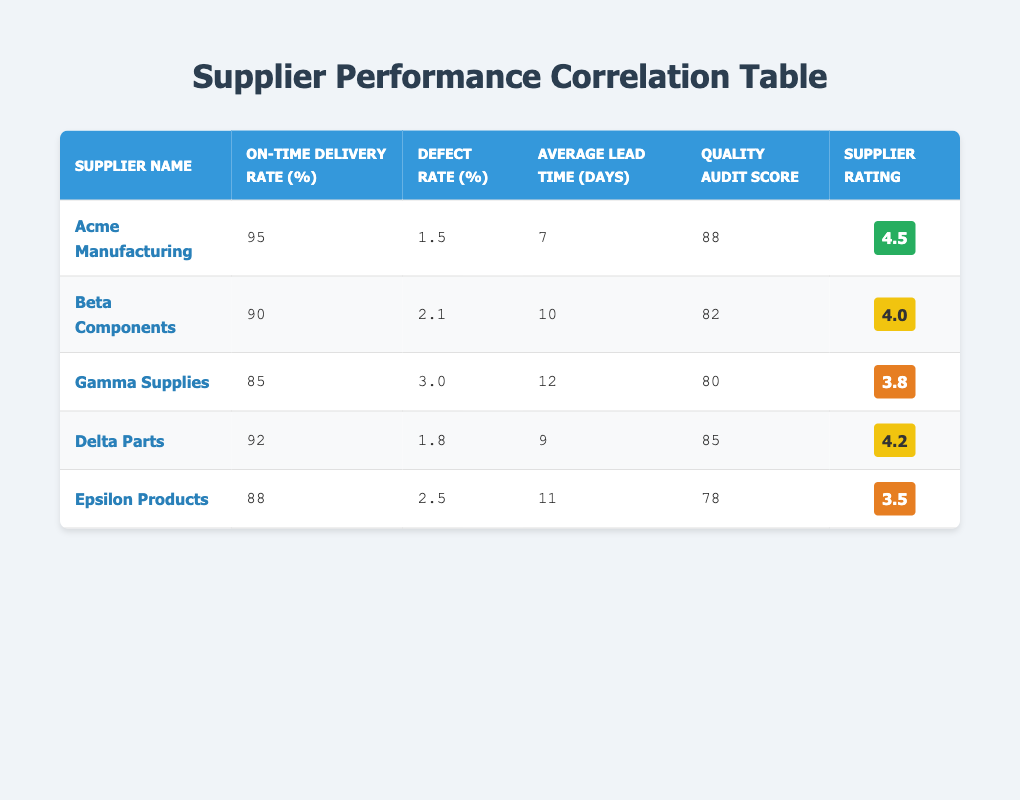What is the defect rate for Acme Manufacturing? The defect rate is listed directly in the table next to Acme Manufacturing, which shows 1.5%.
Answer: 1.5% Which supplier has the highest on-time delivery rate? By comparing the on-time delivery rates from all suppliers in the table, Acme Manufacturing has the highest rate at 95%.
Answer: Acme Manufacturing What is the average defect rate of all suppliers? First, sum all the defect rates: 1.5 + 2.1 + 3.0 + 1.8 + 2.5 = 11.9. Then divide by the number of suppliers (5): 11.9 / 5 = 2.38.
Answer: 2.38 Is the quality audit score of Gamma Supplies higher than that of Delta Parts? Gamma Supplies has a quality audit score of 80, while Delta Parts has a score of 85. Since 80 is less than 85, the answer is no.
Answer: No Which supplier has the lowest supplier rating, and what is that rating? By reviewing the supplier ratings, Epsilon Products has the lowest rating at 3.5.
Answer: Epsilon Products, 3.5 Are there any suppliers with a defect rate lower than 2.0? Looking at the defect rates, Acme Manufacturing (1.5%) and Delta Parts (1.8%) both have rates lower than 2.0%, so the answer is yes.
Answer: Yes What is the average lead time among the suppliers? The lead times are 7, 10, 12, 9, and 11 days. First, sum these: 7 + 10 + 12 + 9 + 11 = 49. Then divide by 5: 49 / 5 = 9.8.
Answer: 9.8 Which supplier has a defect rate that is closest to the average defect rate? The calculated average defect rate was 2.38%. Comparing actual rates, Delta Parts (1.8%) is closest as it has the lowest difference from the average.
Answer: Delta Parts If we exclude the two suppliers with the highest defect rates, what is the average on-time delivery rate for the remaining suppliers? The highest defect rates are from Gamma Supplies (3.0%) and Epsilon Products (2.5%). Excluding these suppliers leaves us with Acme Manufacturing, Beta Components, and Delta Parts. Their on-time delivery rates are 95, 90, and 92 respectively, which sum to 277. The average is 277 / 3 = 92.33.
Answer: 92.33 